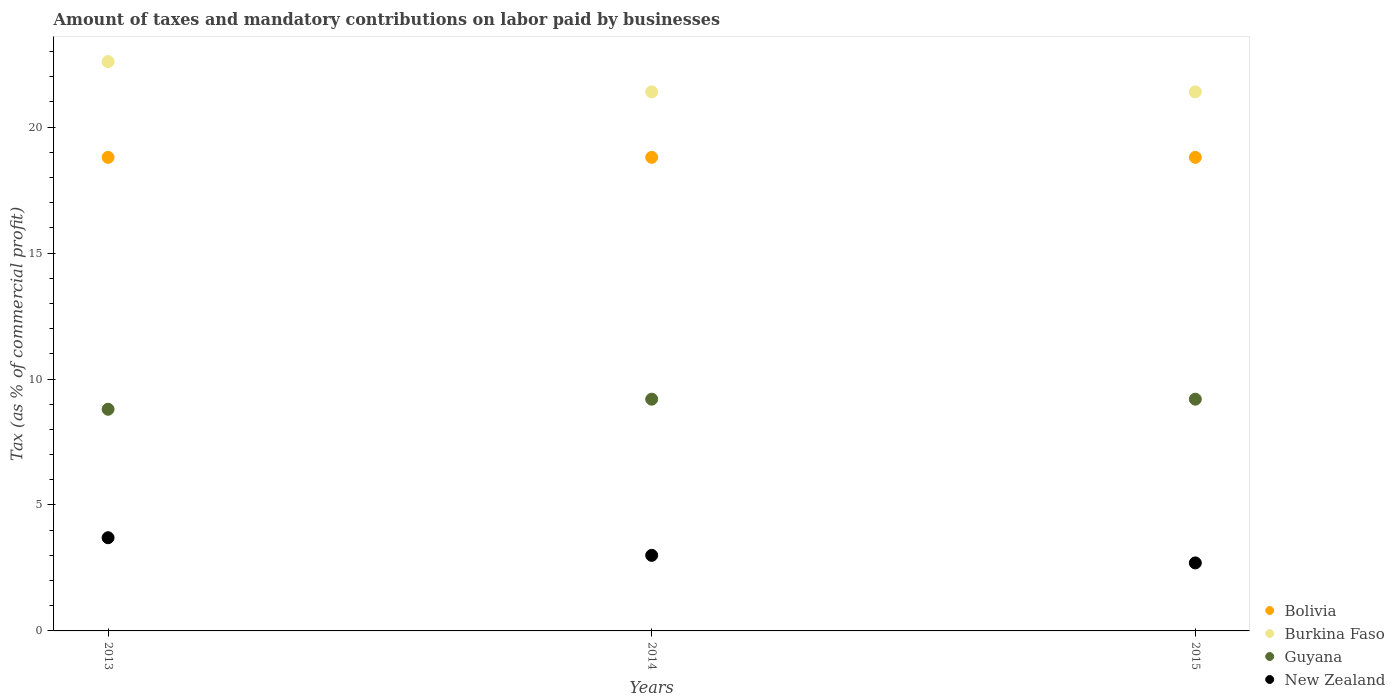How many different coloured dotlines are there?
Ensure brevity in your answer.  4. What is the percentage of taxes paid by businesses in Burkina Faso in 2013?
Keep it short and to the point. 22.6. Across all years, what is the maximum percentage of taxes paid by businesses in Bolivia?
Offer a very short reply. 18.8. Across all years, what is the minimum percentage of taxes paid by businesses in New Zealand?
Give a very brief answer. 2.7. In which year was the percentage of taxes paid by businesses in Guyana maximum?
Provide a succinct answer. 2014. In which year was the percentage of taxes paid by businesses in New Zealand minimum?
Your response must be concise. 2015. What is the total percentage of taxes paid by businesses in Guyana in the graph?
Offer a very short reply. 27.2. What is the difference between the percentage of taxes paid by businesses in Bolivia in 2013 and that in 2014?
Provide a short and direct response. 0. What is the difference between the percentage of taxes paid by businesses in New Zealand in 2015 and the percentage of taxes paid by businesses in Bolivia in 2013?
Your answer should be very brief. -16.1. What is the average percentage of taxes paid by businesses in Bolivia per year?
Your answer should be compact. 18.8. In the year 2015, what is the difference between the percentage of taxes paid by businesses in Burkina Faso and percentage of taxes paid by businesses in Bolivia?
Offer a terse response. 2.6. In how many years, is the percentage of taxes paid by businesses in Burkina Faso greater than 11 %?
Offer a terse response. 3. Is the percentage of taxes paid by businesses in New Zealand in 2014 less than that in 2015?
Ensure brevity in your answer.  No. Is the difference between the percentage of taxes paid by businesses in Burkina Faso in 2013 and 2015 greater than the difference between the percentage of taxes paid by businesses in Bolivia in 2013 and 2015?
Your answer should be compact. Yes. What is the difference between the highest and the lowest percentage of taxes paid by businesses in Guyana?
Your answer should be very brief. 0.4. In how many years, is the percentage of taxes paid by businesses in Burkina Faso greater than the average percentage of taxes paid by businesses in Burkina Faso taken over all years?
Give a very brief answer. 1. Is the percentage of taxes paid by businesses in Burkina Faso strictly greater than the percentage of taxes paid by businesses in New Zealand over the years?
Provide a succinct answer. Yes. How many dotlines are there?
Provide a short and direct response. 4. Does the graph contain any zero values?
Ensure brevity in your answer.  No. Where does the legend appear in the graph?
Your answer should be very brief. Bottom right. How are the legend labels stacked?
Provide a short and direct response. Vertical. What is the title of the graph?
Your response must be concise. Amount of taxes and mandatory contributions on labor paid by businesses. What is the label or title of the X-axis?
Offer a very short reply. Years. What is the label or title of the Y-axis?
Keep it short and to the point. Tax (as % of commercial profit). What is the Tax (as % of commercial profit) of Bolivia in 2013?
Ensure brevity in your answer.  18.8. What is the Tax (as % of commercial profit) in Burkina Faso in 2013?
Your response must be concise. 22.6. What is the Tax (as % of commercial profit) in Burkina Faso in 2014?
Offer a terse response. 21.4. What is the Tax (as % of commercial profit) of Guyana in 2014?
Keep it short and to the point. 9.2. What is the Tax (as % of commercial profit) in Bolivia in 2015?
Provide a short and direct response. 18.8. What is the Tax (as % of commercial profit) of Burkina Faso in 2015?
Provide a short and direct response. 21.4. Across all years, what is the maximum Tax (as % of commercial profit) in Bolivia?
Offer a very short reply. 18.8. Across all years, what is the maximum Tax (as % of commercial profit) in Burkina Faso?
Your response must be concise. 22.6. Across all years, what is the minimum Tax (as % of commercial profit) in Bolivia?
Make the answer very short. 18.8. Across all years, what is the minimum Tax (as % of commercial profit) of Burkina Faso?
Keep it short and to the point. 21.4. Across all years, what is the minimum Tax (as % of commercial profit) in Guyana?
Provide a short and direct response. 8.8. What is the total Tax (as % of commercial profit) of Bolivia in the graph?
Provide a short and direct response. 56.4. What is the total Tax (as % of commercial profit) of Burkina Faso in the graph?
Provide a short and direct response. 65.4. What is the total Tax (as % of commercial profit) in Guyana in the graph?
Ensure brevity in your answer.  27.2. What is the total Tax (as % of commercial profit) of New Zealand in the graph?
Make the answer very short. 9.4. What is the difference between the Tax (as % of commercial profit) of Bolivia in 2013 and that in 2014?
Offer a terse response. 0. What is the difference between the Tax (as % of commercial profit) in Guyana in 2013 and that in 2014?
Provide a short and direct response. -0.4. What is the difference between the Tax (as % of commercial profit) in New Zealand in 2013 and that in 2014?
Make the answer very short. 0.7. What is the difference between the Tax (as % of commercial profit) in Bolivia in 2013 and that in 2015?
Your answer should be compact. 0. What is the difference between the Tax (as % of commercial profit) of Burkina Faso in 2014 and that in 2015?
Give a very brief answer. 0. What is the difference between the Tax (as % of commercial profit) of Guyana in 2014 and that in 2015?
Your answer should be very brief. 0. What is the difference between the Tax (as % of commercial profit) of New Zealand in 2014 and that in 2015?
Provide a short and direct response. 0.3. What is the difference between the Tax (as % of commercial profit) of Bolivia in 2013 and the Tax (as % of commercial profit) of Guyana in 2014?
Keep it short and to the point. 9.6. What is the difference between the Tax (as % of commercial profit) in Bolivia in 2013 and the Tax (as % of commercial profit) in New Zealand in 2014?
Ensure brevity in your answer.  15.8. What is the difference between the Tax (as % of commercial profit) in Burkina Faso in 2013 and the Tax (as % of commercial profit) in Guyana in 2014?
Keep it short and to the point. 13.4. What is the difference between the Tax (as % of commercial profit) in Burkina Faso in 2013 and the Tax (as % of commercial profit) in New Zealand in 2014?
Your answer should be compact. 19.6. What is the difference between the Tax (as % of commercial profit) of Guyana in 2013 and the Tax (as % of commercial profit) of New Zealand in 2014?
Ensure brevity in your answer.  5.8. What is the difference between the Tax (as % of commercial profit) of Bolivia in 2013 and the Tax (as % of commercial profit) of Guyana in 2015?
Your answer should be compact. 9.6. What is the difference between the Tax (as % of commercial profit) of Bolivia in 2013 and the Tax (as % of commercial profit) of New Zealand in 2015?
Give a very brief answer. 16.1. What is the difference between the Tax (as % of commercial profit) of Bolivia in 2014 and the Tax (as % of commercial profit) of Burkina Faso in 2015?
Your response must be concise. -2.6. What is the difference between the Tax (as % of commercial profit) in Bolivia in 2014 and the Tax (as % of commercial profit) in New Zealand in 2015?
Make the answer very short. 16.1. What is the average Tax (as % of commercial profit) of Burkina Faso per year?
Provide a succinct answer. 21.8. What is the average Tax (as % of commercial profit) of Guyana per year?
Give a very brief answer. 9.07. What is the average Tax (as % of commercial profit) in New Zealand per year?
Provide a succinct answer. 3.13. In the year 2013, what is the difference between the Tax (as % of commercial profit) of Bolivia and Tax (as % of commercial profit) of Burkina Faso?
Your answer should be compact. -3.8. In the year 2013, what is the difference between the Tax (as % of commercial profit) of Bolivia and Tax (as % of commercial profit) of Guyana?
Make the answer very short. 10. In the year 2013, what is the difference between the Tax (as % of commercial profit) in Bolivia and Tax (as % of commercial profit) in New Zealand?
Your answer should be very brief. 15.1. In the year 2013, what is the difference between the Tax (as % of commercial profit) of Burkina Faso and Tax (as % of commercial profit) of Guyana?
Offer a terse response. 13.8. In the year 2013, what is the difference between the Tax (as % of commercial profit) of Guyana and Tax (as % of commercial profit) of New Zealand?
Give a very brief answer. 5.1. In the year 2014, what is the difference between the Tax (as % of commercial profit) of Bolivia and Tax (as % of commercial profit) of Guyana?
Provide a short and direct response. 9.6. In the year 2014, what is the difference between the Tax (as % of commercial profit) of Bolivia and Tax (as % of commercial profit) of New Zealand?
Give a very brief answer. 15.8. In the year 2014, what is the difference between the Tax (as % of commercial profit) of Burkina Faso and Tax (as % of commercial profit) of New Zealand?
Provide a succinct answer. 18.4. In the year 2015, what is the difference between the Tax (as % of commercial profit) of Burkina Faso and Tax (as % of commercial profit) of Guyana?
Offer a terse response. 12.2. In the year 2015, what is the difference between the Tax (as % of commercial profit) in Burkina Faso and Tax (as % of commercial profit) in New Zealand?
Make the answer very short. 18.7. In the year 2015, what is the difference between the Tax (as % of commercial profit) in Guyana and Tax (as % of commercial profit) in New Zealand?
Offer a very short reply. 6.5. What is the ratio of the Tax (as % of commercial profit) of Bolivia in 2013 to that in 2014?
Make the answer very short. 1. What is the ratio of the Tax (as % of commercial profit) in Burkina Faso in 2013 to that in 2014?
Make the answer very short. 1.06. What is the ratio of the Tax (as % of commercial profit) of Guyana in 2013 to that in 2014?
Provide a succinct answer. 0.96. What is the ratio of the Tax (as % of commercial profit) of New Zealand in 2013 to that in 2014?
Your answer should be compact. 1.23. What is the ratio of the Tax (as % of commercial profit) in Burkina Faso in 2013 to that in 2015?
Your answer should be compact. 1.06. What is the ratio of the Tax (as % of commercial profit) in Guyana in 2013 to that in 2015?
Your answer should be very brief. 0.96. What is the ratio of the Tax (as % of commercial profit) in New Zealand in 2013 to that in 2015?
Your answer should be compact. 1.37. What is the ratio of the Tax (as % of commercial profit) in Bolivia in 2014 to that in 2015?
Keep it short and to the point. 1. What is the difference between the highest and the second highest Tax (as % of commercial profit) of Burkina Faso?
Offer a very short reply. 1.2. What is the difference between the highest and the second highest Tax (as % of commercial profit) of Guyana?
Keep it short and to the point. 0. What is the difference between the highest and the second highest Tax (as % of commercial profit) of New Zealand?
Your answer should be very brief. 0.7. What is the difference between the highest and the lowest Tax (as % of commercial profit) of Burkina Faso?
Provide a succinct answer. 1.2. 